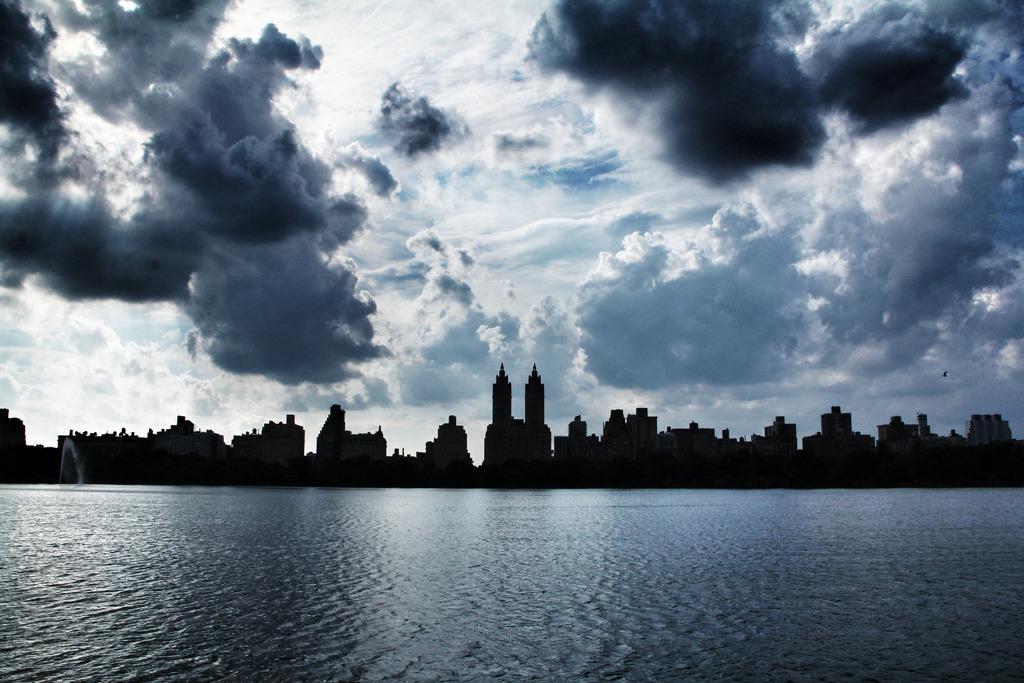In one or two sentences, can you explain what this image depicts? In this image we can see water at the bottom. In the back there are buildings. In the background there is sky with clouds. 